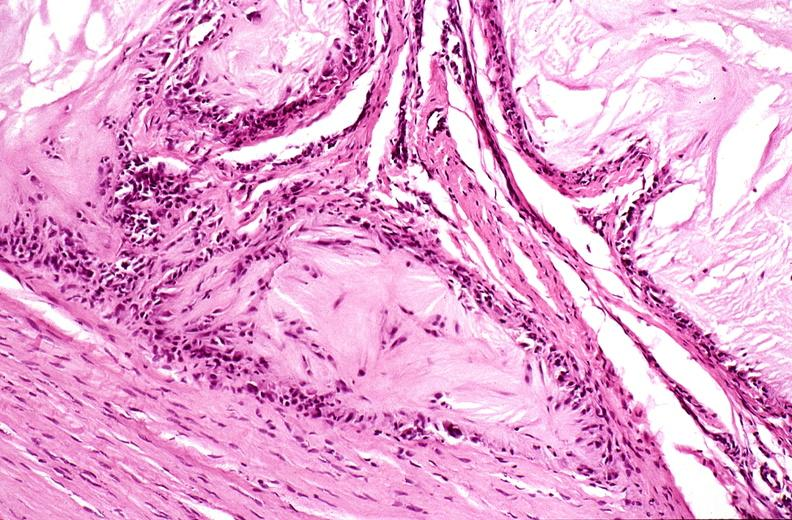does this image show gout?
Answer the question using a single word or phrase. Yes 